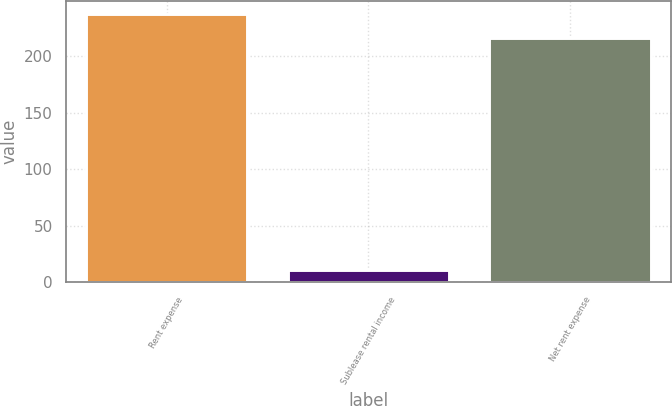Convert chart to OTSL. <chart><loc_0><loc_0><loc_500><loc_500><bar_chart><fcel>Rent expense<fcel>Sublease rental income<fcel>Net rent expense<nl><fcel>237.6<fcel>11<fcel>216<nl></chart> 